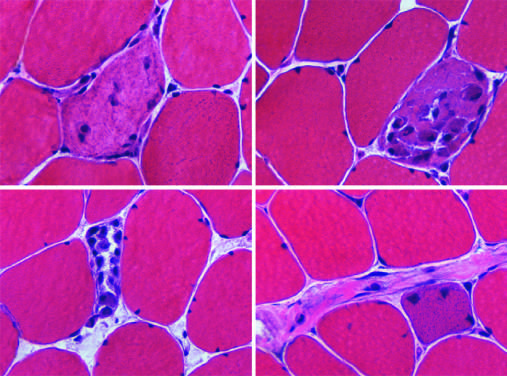what are myopathic conditions associated with?
Answer the question using a single word or phrase. Segmental necrosis and regeneration of individual myofibers 